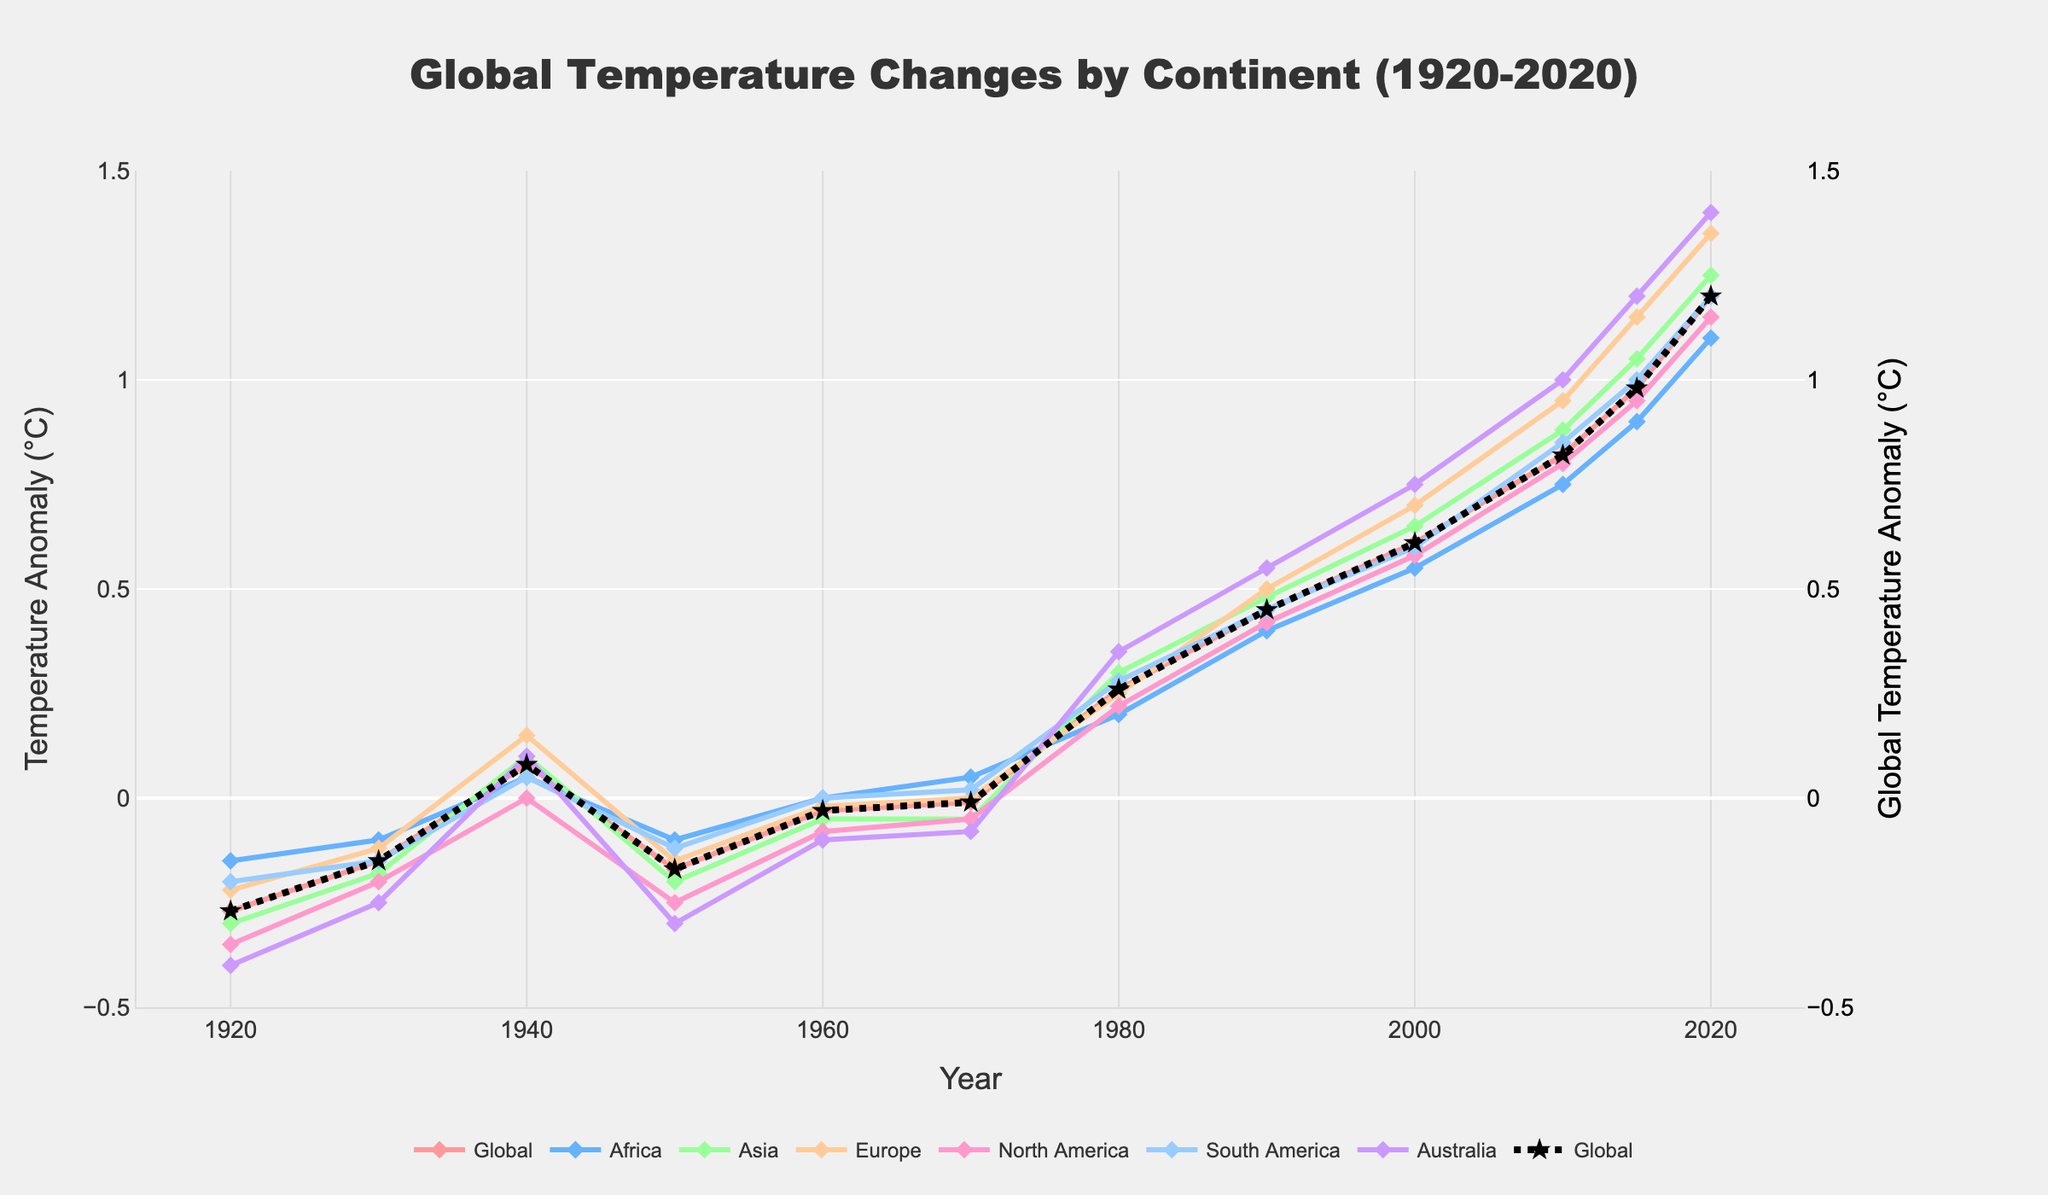Which continent had the highest temperature anomaly in 2020? The highest temperature anomaly can be seen by identifying which line reaches the highest point in the year 2020. This line corresponds to Australia with a temperature anomaly of 1.40°C.
Answer: Australia Which continent showed the lowest temperature anomaly in 1980? To identify this, find the 1980 data points in the chart and look for the one that is visually lowest. Africa had a temperature anomaly of 0.20°C, which is the lowest among all continents.
Answer: Africa How much did the global temperature anomaly increase from 1950 to 2020? First, locate the global temperature anomaly in 1950 which is -0.17°C, then find it in 2020 which is 1.20°C. The increase is 1.20 - (-0.17) = 1.37°C.
Answer: 1.37°C Which year did Europe first reach a positive temperature anomaly? Scanning through each year's data points for Europe, Europe first reached a positive temperature anomaly in 1940 with 0.15°C.
Answer: 1940 By how much did the temperature anomaly in Asia change from 1920 to 1930? Locate the temperature anomaly for Asia in 1920 which is -0.30°C, and in 1930 which is -0.18°C. The change is -0.18 - (-0.30) = 0.12°C.
Answer: 0.12°C In which year did all continents have a positive temperature anomaly for the first time? Look for the first year where the lines of all continents are above the zero line. This occurs in 1980.
Answer: 1980 Which continent experienced the biggest increase in temperature anomaly from 2010 to 2020? Check the data points for each continent in 2010 and 2020 and find the difference. Australia's increase is the largest from 1.00°C to 1.40°C, which is 0.40°C.
Answer: Australia Compare the temperature anomaly of North America and South America in 2000. Which continent had a higher anomaly? Identify the data points for both continents in 2000. North America had a value of 0.58°C and South America had 0.60°C. South America had a higher anomaly.
Answer: South America How did the temperature anomaly in Africa change from 1970 to 1990? Locate Africa's temperature anomalies in 1970 (0.05°C) and in 1990 (0.40°C). Calculate the change: 0.40 - 0.05 = 0.35°C.
Answer: 0.35°C Was the global temperature anomaly ever negative after 1980? By scanning the global temperature anomaly line (black), see if any points are below the zero line after 1980. All are above zero, indicating no negative anomalies after 1980.
Answer: No 